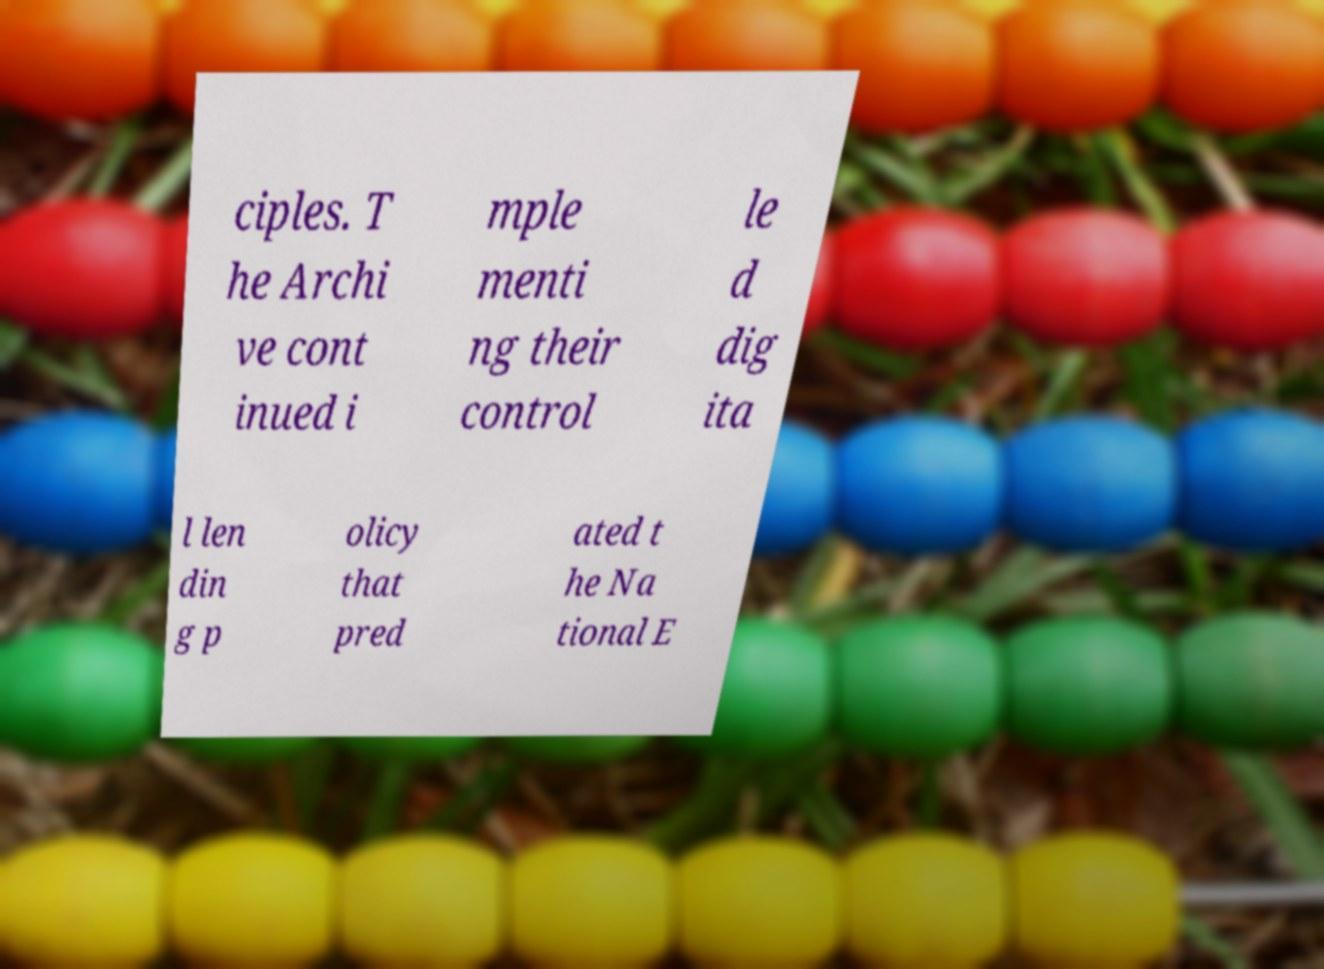For documentation purposes, I need the text within this image transcribed. Could you provide that? ciples. T he Archi ve cont inued i mple menti ng their control le d dig ita l len din g p olicy that pred ated t he Na tional E 